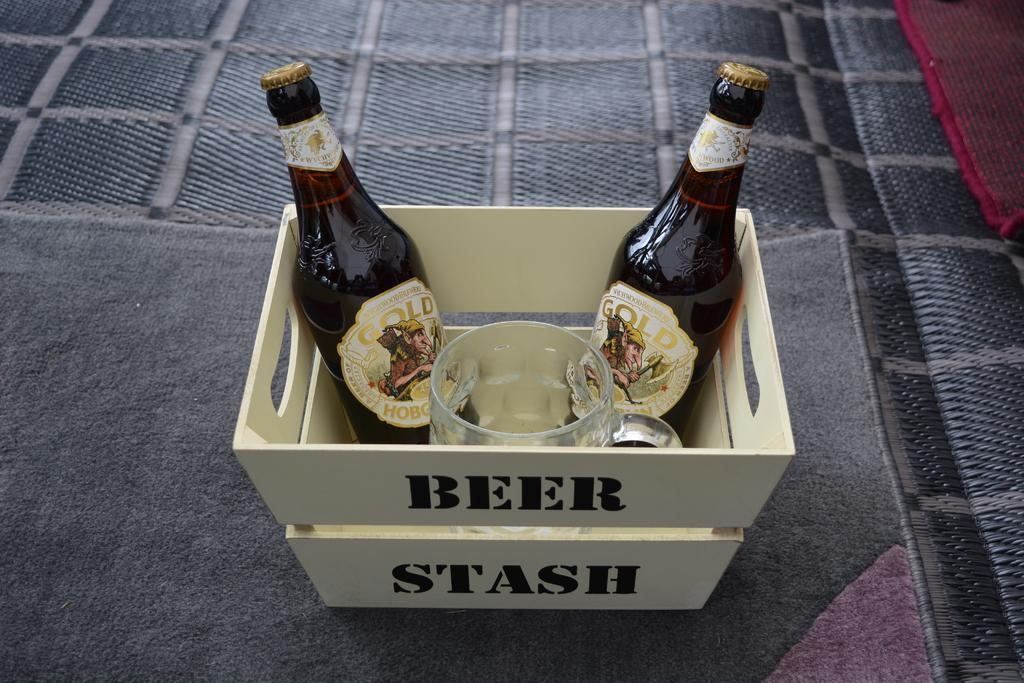<image>
Describe the image concisely. A crate labeled beer stash holds bottles and a glass mug. 